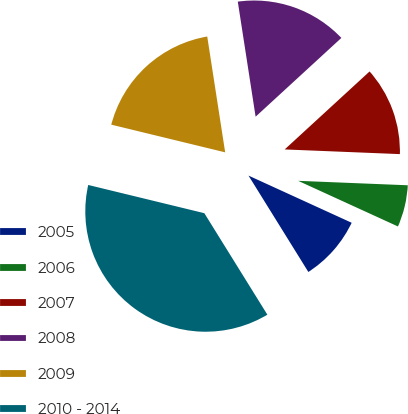Convert chart. <chart><loc_0><loc_0><loc_500><loc_500><pie_chart><fcel>2005<fcel>2006<fcel>2007<fcel>2008<fcel>2009<fcel>2010 - 2014<nl><fcel>9.33%<fcel>6.18%<fcel>12.47%<fcel>15.62%<fcel>18.76%<fcel>37.64%<nl></chart> 